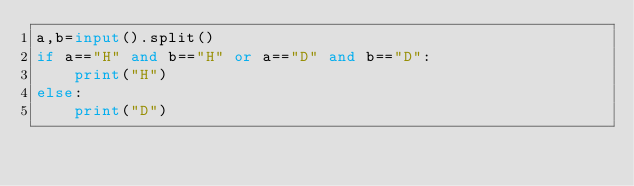<code> <loc_0><loc_0><loc_500><loc_500><_Python_>a,b=input().split()
if a=="H" and b=="H" or a=="D" and b=="D":
    print("H")
else:
    print("D")</code> 